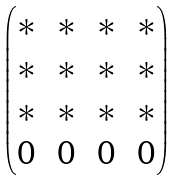<formula> <loc_0><loc_0><loc_500><loc_500>\begin{pmatrix} * \, & * \, & * \, & * \\ * \, & * \, & * \, & * \\ * \, & * \, & * \, & * \\ 0 \, & 0 \, & 0 \, & 0 \end{pmatrix}</formula> 